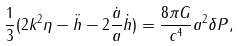Convert formula to latex. <formula><loc_0><loc_0><loc_500><loc_500>\frac { 1 } { 3 } ( 2 k ^ { 2 } \eta - \ddot { h } - 2 \frac { \dot { a } } { a } \dot { h } ) = \frac { 8 \pi G } { c ^ { 4 } } a ^ { 2 } \delta P ,</formula> 